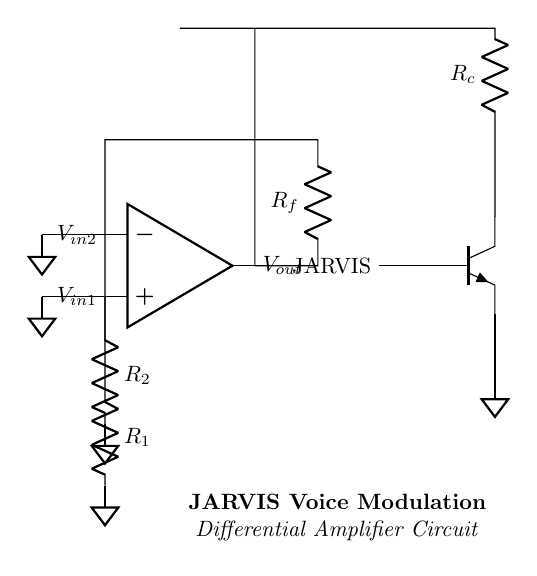What is the type of amplifier in this circuit? The circuit is a differential amplifier, which uses two input voltages and amplifies the difference between them. The op-amp configuration indicates it is a differential setup.
Answer: Differential amplifier What are the resistor values indicated in the circuit? The circuit shows three resistors: R1, R2, and Rf. However, specific numerical values are not provided, only the labels identify their positions and roles in the circuit.
Answer: R1, R2, Rf What is connected to the inverting input of the op-amp? The inverting input of the op-amp is connected to the voltage through resistor R2. This connection is crucial for the differential operation as it subtracts the input voltages.
Answer: R2 What component is used to symbolically represent JARVIS in the circuit? The component used to represent JARVIS is the NPN transistor, which is labeled in the circuit diagram. This indicates that the transistor is involved in the modulation of the signal processed by the differential amplifier.
Answer: NPN transistor How many ground connections are present in this circuit? There are three ground connections in the circuit, each connected to the inverting and non-inverting inputs and the emitter of the NPN transistor. This ensures that the circuit has a common reference point.
Answer: Three What is the function of resistor Rf in this circuit? Resistor Rf is part of the feedback loop in the differential amplifier. It helps set the gain of the amplifier and determines how much of the output voltage is fed back to the inverting input, influencing the overall amplification of the input signal difference.
Answer: Feedback What does the label "Vout" represent in the circuit? The label "Vout" represents the output voltage of the differential amplifier. It indicates the amplified difference between the two input voltages, which results from the process of amplification that the op-amp performs with the input signals.
Answer: Output voltage 